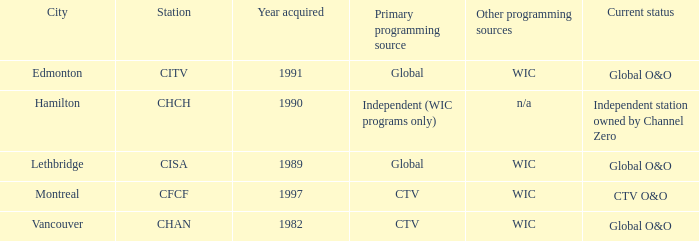Where is citv located Edmonton. 